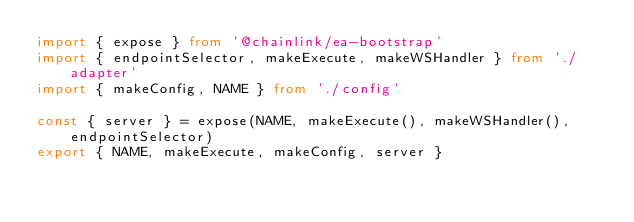<code> <loc_0><loc_0><loc_500><loc_500><_TypeScript_>import { expose } from '@chainlink/ea-bootstrap'
import { endpointSelector, makeExecute, makeWSHandler } from './adapter'
import { makeConfig, NAME } from './config'

const { server } = expose(NAME, makeExecute(), makeWSHandler(), endpointSelector)
export { NAME, makeExecute, makeConfig, server }
</code> 